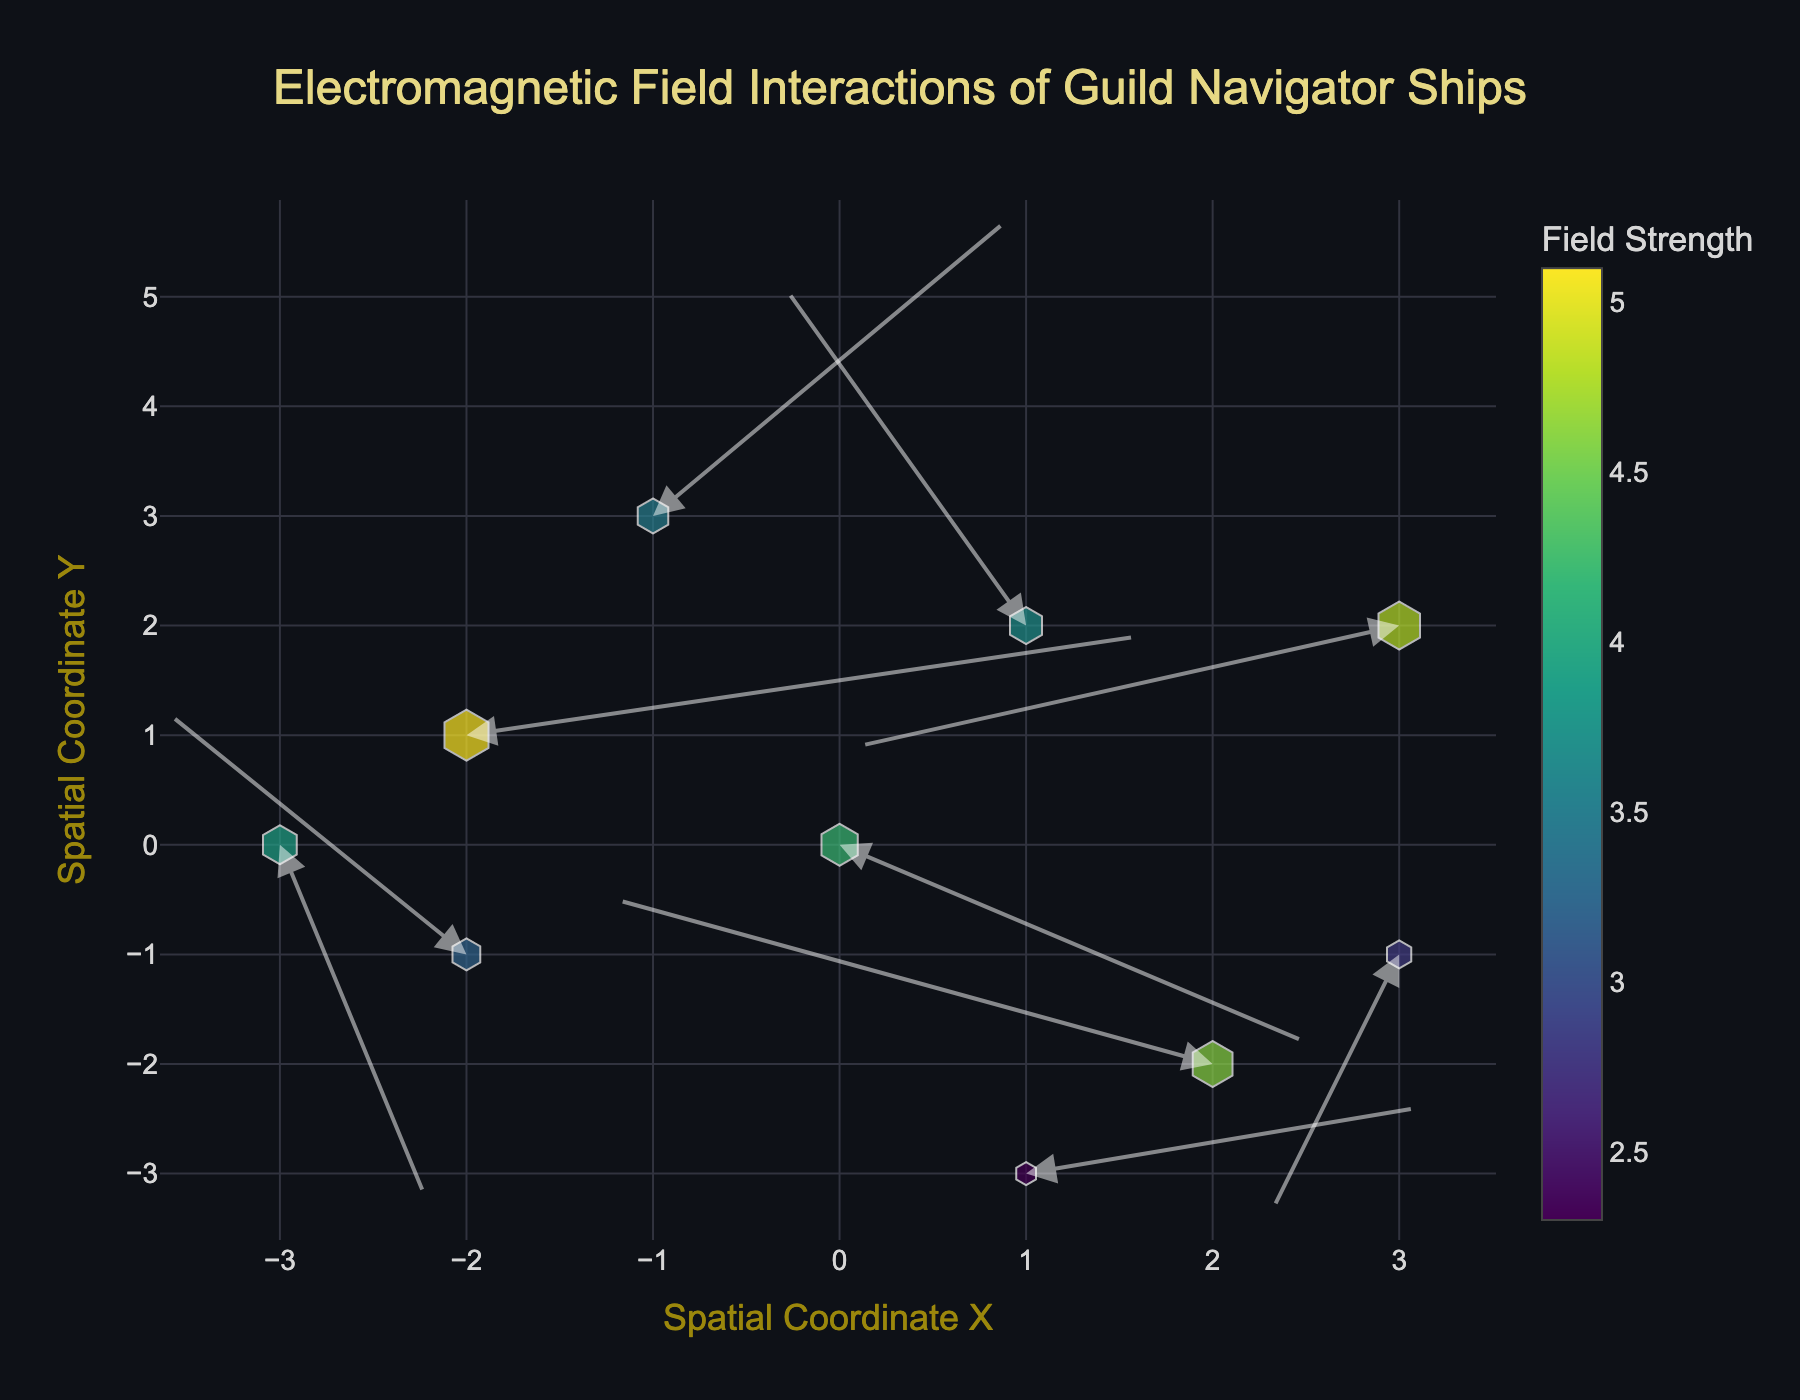What's the title of the figure? The title of the figure is displayed at the top center of the image in larger font size and typically in a distinct color compared to other text elements.
Answer: Electromagnetic Field Interactions of Guild Navigator Ships How many data points are shown in the plot? To determine the number of data points, you can count the number of markers or arrows in the plot.
Answer: 10 Which data point has the highest electromagnetic field strength? Check the color and size of the markers. The marker with the darkest color and largest size corresponds to the highest strength value, which you can verify by hovering over the marker for confirmation.
Answer: (-2, 1) What is the pattern of the electromagnetic field strength distribution? Observe the color and size of the markers from the plot's color scale. Larger and darker markers indicate higher strength, and smaller/lighter markers indicate lower strength. Describe any evident gradient or clustering.
Answer: The highest strengths are in the center and lower left of the plot, with lower strengths scattered around Which data point shows the largest horizontal movement? Look at the length of the arrows in the horizontal (X-axis) direction. The data point with the longest arrow in the horizontal direction has the largest horizontal movement.
Answer: (2, -2) What are the spatial coordinates of the data point with the largest vertical movement? Look for the arrow extending the farthest vertically (Y-axis direction). The arrow's base gives the coordinates.
Answer: (1, 2) Compare the field strength at (3, 2) and (-2, -1). Which one is stronger? Evaluate the marker sizes and colors at these coordinates. The marker with the darker color and larger marker has a higher strength.
Answer: (3, 2) For the data point located at (0, 0), what are the U and V components of the vector? The U and V components represent the horizontal and vertical direction and length of the arrow starting at (0, 0).
Answer: U=2.5, V=-1.8 What is the average electromagnetic field strength of the data points? Sum all the strength values of each data point and divide by the total number of data points.
Answer: 3.81 At the coordinate (1, -3), in which direction does the vector point? Examine the direction of the arrow originating from (1, -3). Note the direction it points in terms of X and Y coordinates.
Answer: Up and to the right 